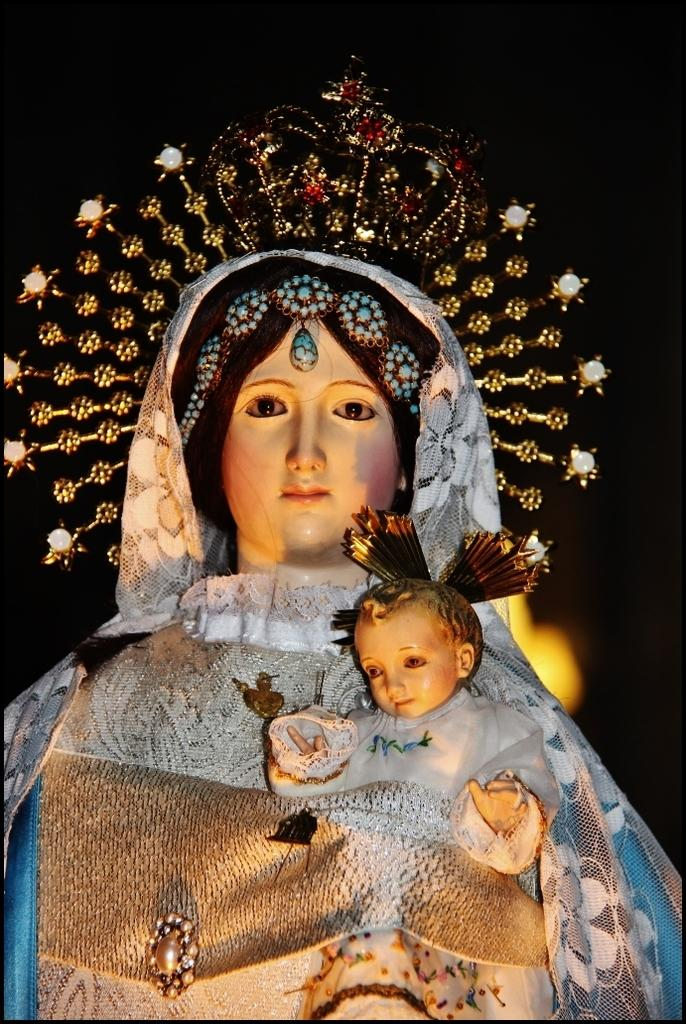What is the main subject of the image? There is a statue of a woman holding a baby in the image. What is the color of the background in the image? There is a black background in the image. Can you describe any other elements in the image? There is a light in the image. What type of box is being used for payment in the image? There is no box or payment being depicted in the image; it features a statue of a woman holding a baby against a black background with a light. 